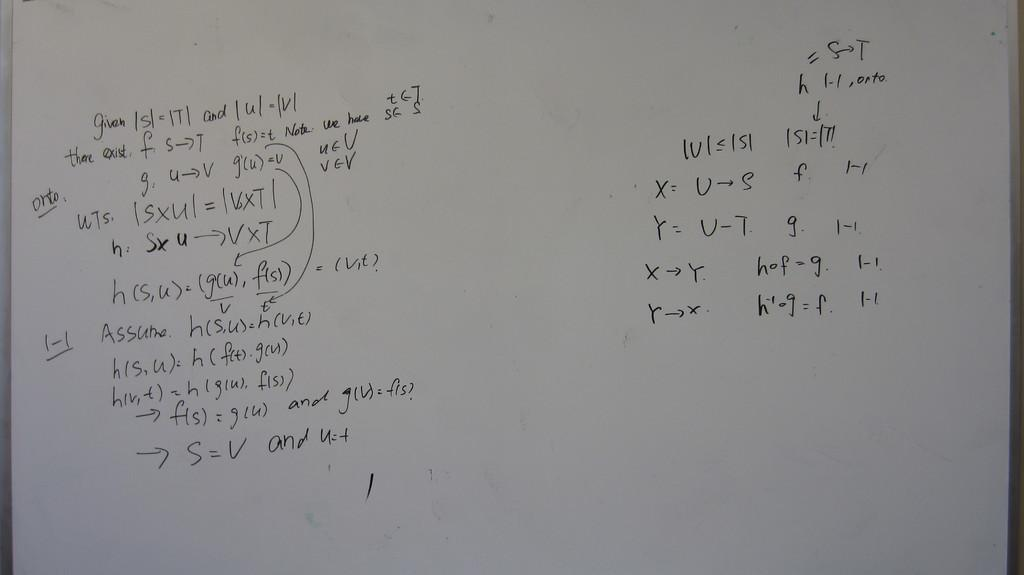Provide a one-sentence caption for the provided image. a white board close up with words "Given | s|" on it. 